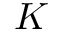<formula> <loc_0><loc_0><loc_500><loc_500>K</formula> 